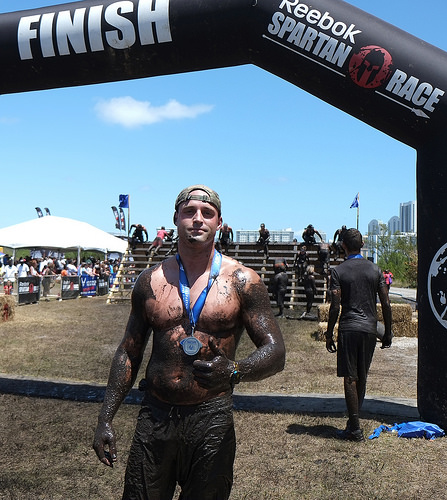<image>
Is there a man in front of the archway? Yes. The man is positioned in front of the archway, appearing closer to the camera viewpoint. Where is the man in relation to the sky? Is it in front of the sky? No. The man is not in front of the sky. The spatial positioning shows a different relationship between these objects. 